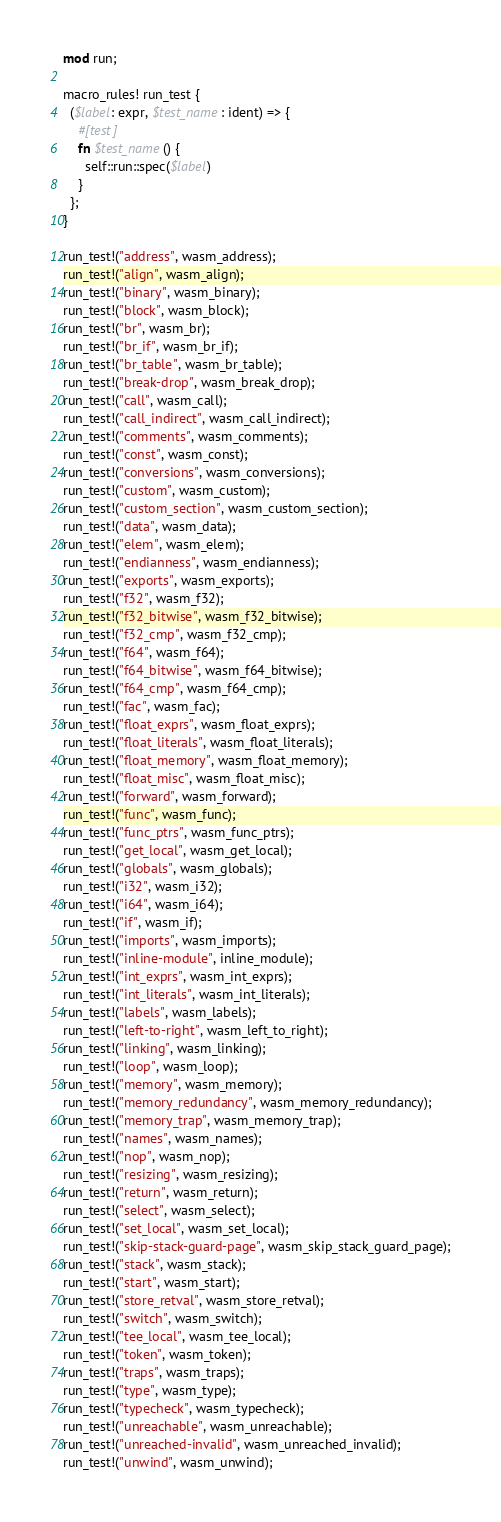<code> <loc_0><loc_0><loc_500><loc_500><_Rust_>mod run;

macro_rules! run_test {
  ($label: expr, $test_name: ident) => {
    #[test]
    fn $test_name() {
      self::run::spec($label)
    }
  };
}

run_test!("address", wasm_address);
run_test!("align", wasm_align);
run_test!("binary", wasm_binary);
run_test!("block", wasm_block);
run_test!("br", wasm_br);
run_test!("br_if", wasm_br_if);
run_test!("br_table", wasm_br_table);
run_test!("break-drop", wasm_break_drop);
run_test!("call", wasm_call);
run_test!("call_indirect", wasm_call_indirect);
run_test!("comments", wasm_comments);
run_test!("const", wasm_const);
run_test!("conversions", wasm_conversions);
run_test!("custom", wasm_custom);
run_test!("custom_section", wasm_custom_section);
run_test!("data", wasm_data);
run_test!("elem", wasm_elem);
run_test!("endianness", wasm_endianness);
run_test!("exports", wasm_exports);
run_test!("f32", wasm_f32);
run_test!("f32_bitwise", wasm_f32_bitwise);
run_test!("f32_cmp", wasm_f32_cmp);
run_test!("f64", wasm_f64);
run_test!("f64_bitwise", wasm_f64_bitwise);
run_test!("f64_cmp", wasm_f64_cmp);
run_test!("fac", wasm_fac);
run_test!("float_exprs", wasm_float_exprs);
run_test!("float_literals", wasm_float_literals);
run_test!("float_memory", wasm_float_memory);
run_test!("float_misc", wasm_float_misc);
run_test!("forward", wasm_forward);
run_test!("func", wasm_func);
run_test!("func_ptrs", wasm_func_ptrs);
run_test!("get_local", wasm_get_local);
run_test!("globals", wasm_globals);
run_test!("i32", wasm_i32);
run_test!("i64", wasm_i64);
run_test!("if", wasm_if);
run_test!("imports", wasm_imports);
run_test!("inline-module", inline_module);
run_test!("int_exprs", wasm_int_exprs);
run_test!("int_literals", wasm_int_literals);
run_test!("labels", wasm_labels);
run_test!("left-to-right", wasm_left_to_right);
run_test!("linking", wasm_linking);
run_test!("loop", wasm_loop);
run_test!("memory", wasm_memory);
run_test!("memory_redundancy", wasm_memory_redundancy);
run_test!("memory_trap", wasm_memory_trap);
run_test!("names", wasm_names);
run_test!("nop", wasm_nop);
run_test!("resizing", wasm_resizing);
run_test!("return", wasm_return);
run_test!("select", wasm_select);
run_test!("set_local", wasm_set_local);
run_test!("skip-stack-guard-page", wasm_skip_stack_guard_page);
run_test!("stack", wasm_stack);
run_test!("start", wasm_start);
run_test!("store_retval", wasm_store_retval);
run_test!("switch", wasm_switch);
run_test!("tee_local", wasm_tee_local);
run_test!("token", wasm_token);
run_test!("traps", wasm_traps);
run_test!("type", wasm_type);
run_test!("typecheck", wasm_typecheck);
run_test!("unreachable", wasm_unreachable);
run_test!("unreached-invalid", wasm_unreached_invalid);
run_test!("unwind", wasm_unwind);</code> 